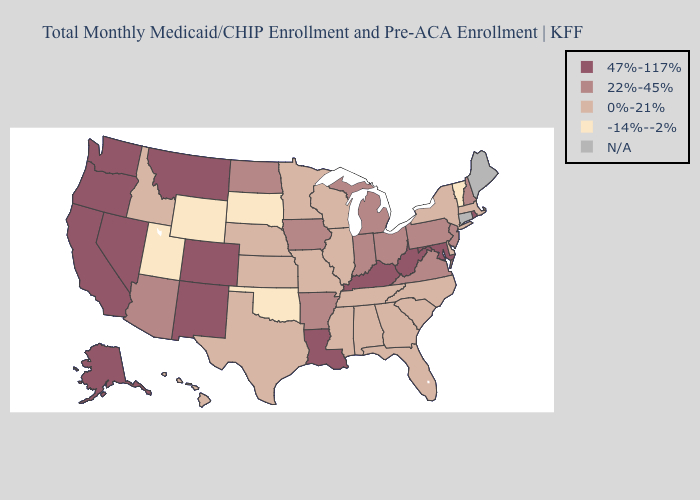Does the map have missing data?
Concise answer only. Yes. Does the map have missing data?
Give a very brief answer. Yes. Among the states that border Washington , does Idaho have the highest value?
Give a very brief answer. No. Name the states that have a value in the range 0%-21%?
Keep it brief. Alabama, Delaware, Florida, Georgia, Hawaii, Idaho, Illinois, Kansas, Massachusetts, Minnesota, Mississippi, Missouri, Nebraska, New York, North Carolina, South Carolina, Tennessee, Texas, Wisconsin. Among the states that border Montana , which have the lowest value?
Quick response, please. South Dakota, Wyoming. What is the value of Utah?
Be succinct. -14%--2%. What is the value of Utah?
Give a very brief answer. -14%--2%. What is the value of Pennsylvania?
Short answer required. 22%-45%. What is the value of Montana?
Answer briefly. 47%-117%. What is the lowest value in the USA?
Give a very brief answer. -14%--2%. Name the states that have a value in the range 22%-45%?
Short answer required. Arizona, Arkansas, Indiana, Iowa, Michigan, New Hampshire, New Jersey, North Dakota, Ohio, Pennsylvania, Virginia. Does New York have the lowest value in the USA?
Short answer required. No. What is the lowest value in the Northeast?
Concise answer only. -14%--2%. 